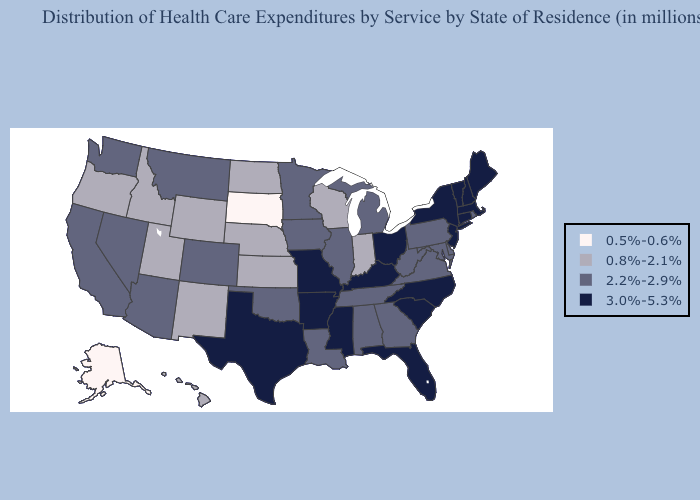Among the states that border Indiana , does Kentucky have the lowest value?
Give a very brief answer. No. Name the states that have a value in the range 3.0%-5.3%?
Give a very brief answer. Arkansas, Connecticut, Florida, Kentucky, Maine, Massachusetts, Mississippi, Missouri, New Hampshire, New Jersey, New York, North Carolina, Ohio, South Carolina, Texas, Vermont. Among the states that border Arizona , does Utah have the highest value?
Be succinct. No. Does the first symbol in the legend represent the smallest category?
Quick response, please. Yes. Does New Mexico have a higher value than Washington?
Concise answer only. No. Among the states that border Colorado , does Arizona have the lowest value?
Give a very brief answer. No. Name the states that have a value in the range 3.0%-5.3%?
Quick response, please. Arkansas, Connecticut, Florida, Kentucky, Maine, Massachusetts, Mississippi, Missouri, New Hampshire, New Jersey, New York, North Carolina, Ohio, South Carolina, Texas, Vermont. What is the value of Colorado?
Answer briefly. 2.2%-2.9%. What is the highest value in states that border Rhode Island?
Give a very brief answer. 3.0%-5.3%. Does Arizona have a higher value than Missouri?
Be succinct. No. Among the states that border North Carolina , which have the highest value?
Give a very brief answer. South Carolina. What is the lowest value in the USA?
Quick response, please. 0.5%-0.6%. What is the value of Vermont?
Write a very short answer. 3.0%-5.3%. What is the highest value in states that border Oregon?
Give a very brief answer. 2.2%-2.9%. 